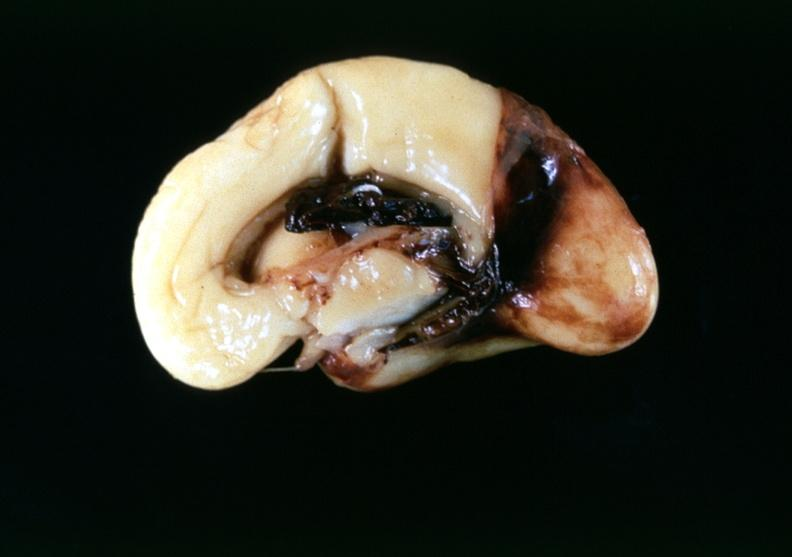does this image show brain, intraventricular hemmorrhage in a prematue baby with hyaline membrane disease?
Answer the question using a single word or phrase. Yes 